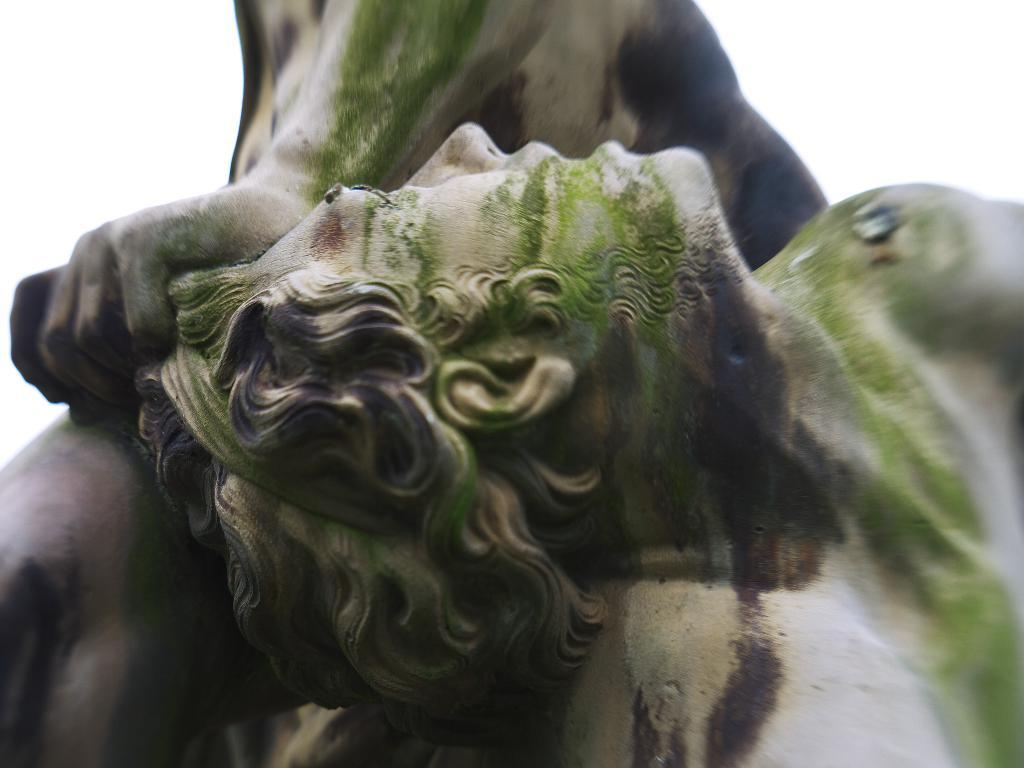What objects are present in the image? There are statues in the image. What color is the background of the image? The background of the image is white. What type of connection can be seen between the statues in the image? There is no visible connection between the statues in the image. What kind of rock is present in the image? There is no rock present in the image; it features statues and a white background. 